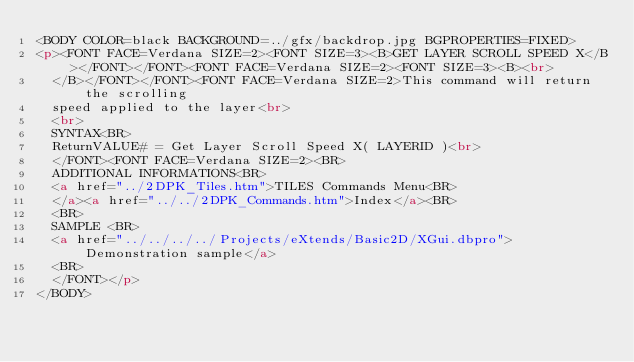<code> <loc_0><loc_0><loc_500><loc_500><_HTML_><BODY COLOR=black BACKGROUND=../gfx/backdrop.jpg BGPROPERTIES=FIXED>
<p><FONT FACE=Verdana SIZE=2><FONT SIZE=3><B>GET LAYER SCROLL SPEED X</B></FONT></FONT><FONT FACE=Verdana SIZE=2><FONT SIZE=3><B><br>
  </B></FONT></FONT><FONT FACE=Verdana SIZE=2>This command will return the scrolling 
  speed applied to the layer<br>
  <br>
  SYNTAX<BR>
  ReturnVALUE# = Get Layer Scroll Speed X( LAYERID )<br>
  </FONT><FONT FACE=Verdana SIZE=2><BR>
  ADDITIONAL INFORMATIONS<BR>
  <a href="../2DPK_Tiles.htm">TILES Commands Menu<BR>
  </a><a href="../../2DPK_Commands.htm">Index</a><BR>
  <BR>
  SAMPLE <BR>
  <a href="../../../../Projects/eXtends/Basic2D/XGui.dbpro">Demonstration sample</a> 
  <BR>
  </FONT></p>
</BODY></code> 